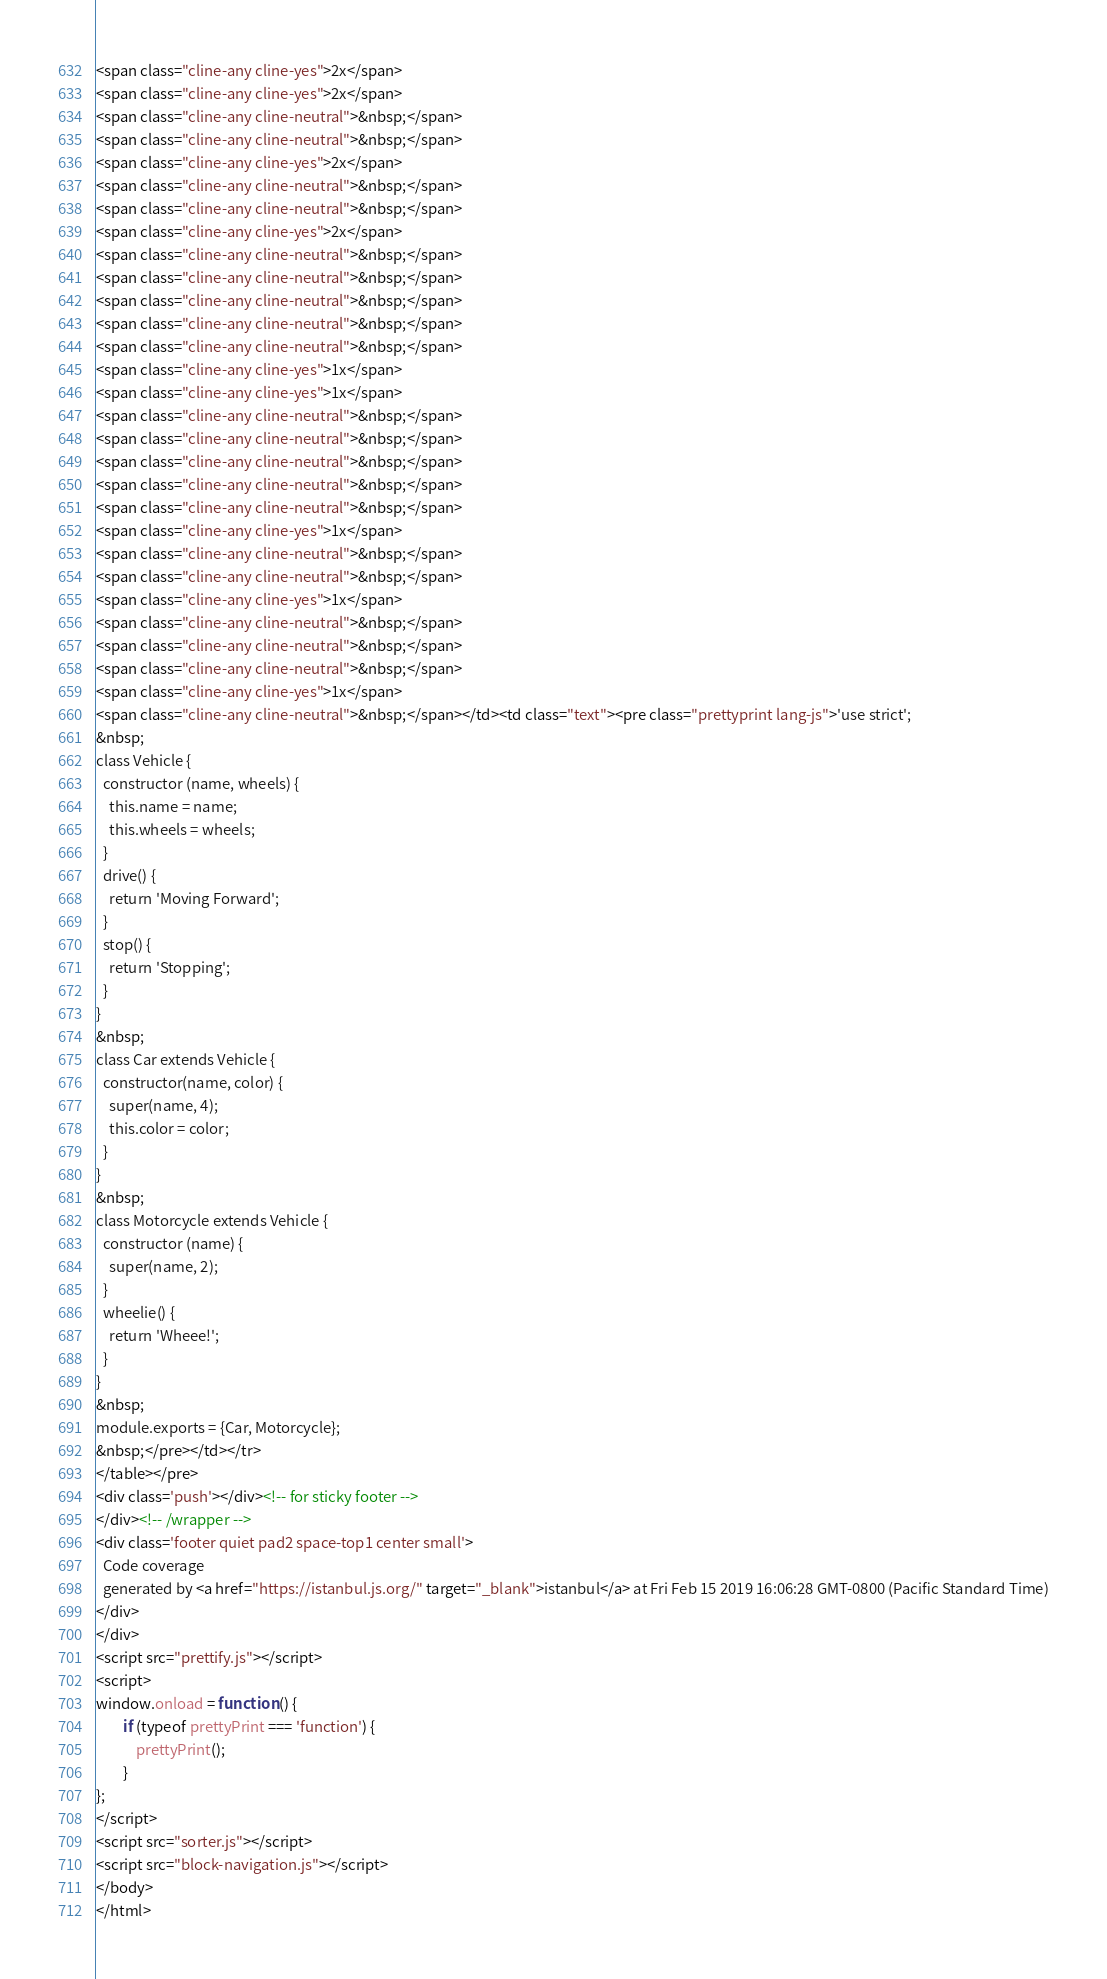<code> <loc_0><loc_0><loc_500><loc_500><_HTML_><span class="cline-any cline-yes">2x</span>
<span class="cline-any cline-yes">2x</span>
<span class="cline-any cline-neutral">&nbsp;</span>
<span class="cline-any cline-neutral">&nbsp;</span>
<span class="cline-any cline-yes">2x</span>
<span class="cline-any cline-neutral">&nbsp;</span>
<span class="cline-any cline-neutral">&nbsp;</span>
<span class="cline-any cline-yes">2x</span>
<span class="cline-any cline-neutral">&nbsp;</span>
<span class="cline-any cline-neutral">&nbsp;</span>
<span class="cline-any cline-neutral">&nbsp;</span>
<span class="cline-any cline-neutral">&nbsp;</span>
<span class="cline-any cline-neutral">&nbsp;</span>
<span class="cline-any cline-yes">1x</span>
<span class="cline-any cline-yes">1x</span>
<span class="cline-any cline-neutral">&nbsp;</span>
<span class="cline-any cline-neutral">&nbsp;</span>
<span class="cline-any cline-neutral">&nbsp;</span>
<span class="cline-any cline-neutral">&nbsp;</span>
<span class="cline-any cline-neutral">&nbsp;</span>
<span class="cline-any cline-yes">1x</span>
<span class="cline-any cline-neutral">&nbsp;</span>
<span class="cline-any cline-neutral">&nbsp;</span>
<span class="cline-any cline-yes">1x</span>
<span class="cline-any cline-neutral">&nbsp;</span>
<span class="cline-any cline-neutral">&nbsp;</span>
<span class="cline-any cline-neutral">&nbsp;</span>
<span class="cline-any cline-yes">1x</span>
<span class="cline-any cline-neutral">&nbsp;</span></td><td class="text"><pre class="prettyprint lang-js">'use strict';
&nbsp;
class Vehicle {
  constructor (name, wheels) {
    this.name = name;
    this.wheels = wheels;
  }
  drive() {
    return 'Moving Forward';
  }
  stop() {
    return 'Stopping';
  }
}
&nbsp;
class Car extends Vehicle {
  constructor(name, color) {
    super(name, 4);
    this.color = color;
  }
}
&nbsp;
class Motorcycle extends Vehicle {
  constructor (name) {
    super(name, 2);
  }
  wheelie() {
    return 'Wheee!';
  }
}
&nbsp;
module.exports = {Car, Motorcycle};
&nbsp;</pre></td></tr>
</table></pre>
<div class='push'></div><!-- for sticky footer -->
</div><!-- /wrapper -->
<div class='footer quiet pad2 space-top1 center small'>
  Code coverage
  generated by <a href="https://istanbul.js.org/" target="_blank">istanbul</a> at Fri Feb 15 2019 16:06:28 GMT-0800 (Pacific Standard Time)
</div>
</div>
<script src="prettify.js"></script>
<script>
window.onload = function () {
        if (typeof prettyPrint === 'function') {
            prettyPrint();
        }
};
</script>
<script src="sorter.js"></script>
<script src="block-navigation.js"></script>
</body>
</html>
</code> 